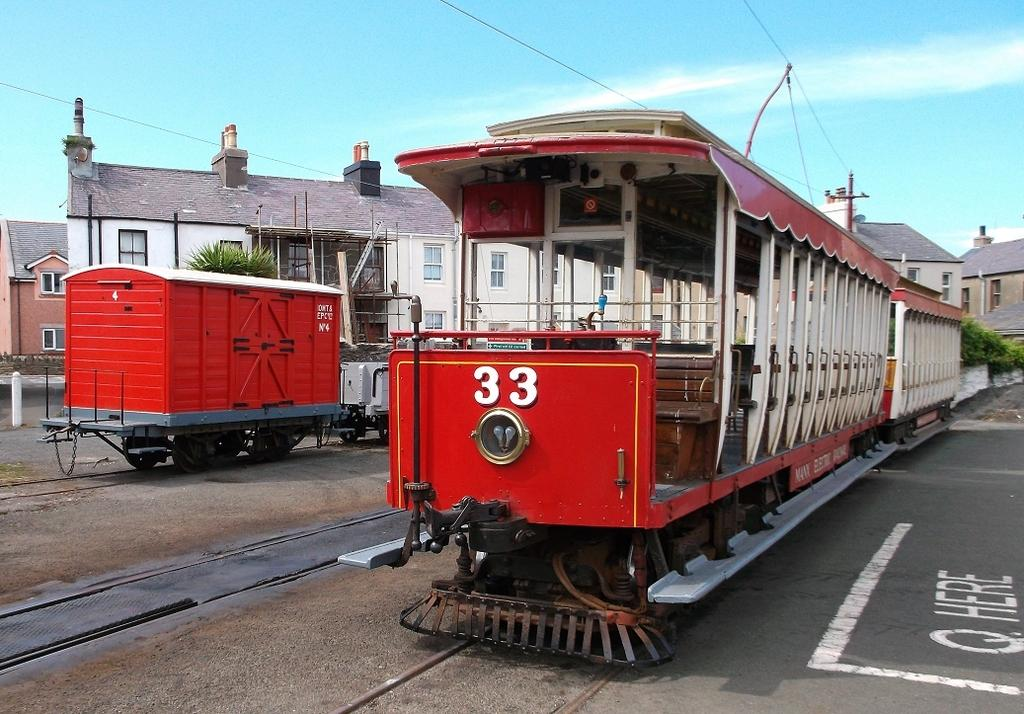What is the main subject of the image? The main subject of the image is trains on railway tracks. What can be seen in the background of the image? In the background of the image, there are trees, buildings, poles with wires, and the sky. What is the condition of the road in the image? The road in the image has white lines and something written on it. What type of amusement can be seen on the trains in the image? There is no amusement present on the trains in the image; they are simply on the railway tracks. What is the iron content of the trees in the image? There is no information about the iron content of the trees in the image, as it is not relevant to the image's content. 